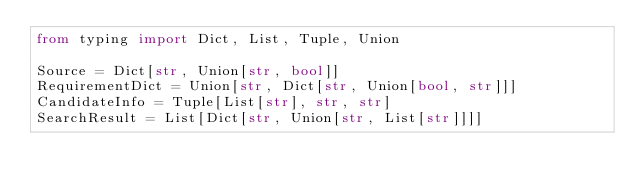Convert code to text. <code><loc_0><loc_0><loc_500><loc_500><_Python_>from typing import Dict, List, Tuple, Union

Source = Dict[str, Union[str, bool]]
RequirementDict = Union[str, Dict[str, Union[bool, str]]]
CandidateInfo = Tuple[List[str], str, str]
SearchResult = List[Dict[str, Union[str, List[str]]]]
</code> 